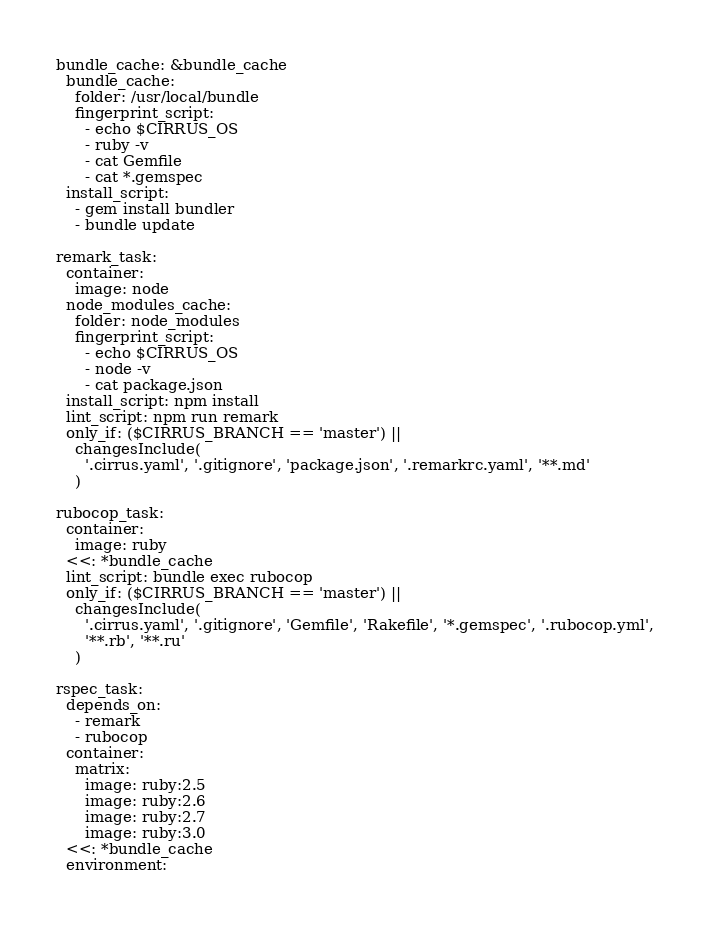Convert code to text. <code><loc_0><loc_0><loc_500><loc_500><_YAML_>bundle_cache: &bundle_cache
  bundle_cache:
    folder: /usr/local/bundle
    fingerprint_script:
      - echo $CIRRUS_OS
      - ruby -v
      - cat Gemfile
      - cat *.gemspec
  install_script:
    - gem install bundler
    - bundle update

remark_task:
  container:
    image: node
  node_modules_cache:
    folder: node_modules
    fingerprint_script:
      - echo $CIRRUS_OS
      - node -v
      - cat package.json
  install_script: npm install
  lint_script: npm run remark
  only_if: ($CIRRUS_BRANCH == 'master') ||
    changesInclude(
      '.cirrus.yaml', '.gitignore', 'package.json', '.remarkrc.yaml', '**.md'
    )

rubocop_task:
  container:
    image: ruby
  <<: *bundle_cache
  lint_script: bundle exec rubocop
  only_if: ($CIRRUS_BRANCH == 'master') ||
    changesInclude(
      '.cirrus.yaml', '.gitignore', 'Gemfile', 'Rakefile', '*.gemspec', '.rubocop.yml',
      '**.rb', '**.ru'
    )

rspec_task:
  depends_on:
    - remark
    - rubocop
  container:
    matrix:
      image: ruby:2.5
      image: ruby:2.6
      image: ruby:2.7
      image: ruby:3.0
  <<: *bundle_cache
  environment:</code> 